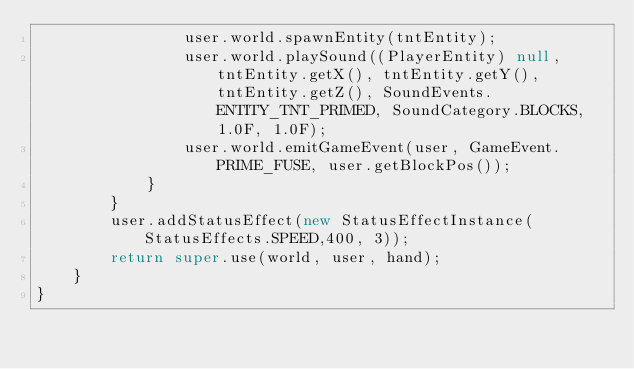Convert code to text. <code><loc_0><loc_0><loc_500><loc_500><_Java_>                user.world.spawnEntity(tntEntity);
                user.world.playSound((PlayerEntity) null, tntEntity.getX(), tntEntity.getY(), tntEntity.getZ(), SoundEvents.ENTITY_TNT_PRIMED, SoundCategory.BLOCKS, 1.0F, 1.0F);
                user.world.emitGameEvent(user, GameEvent.PRIME_FUSE, user.getBlockPos());
            }
        }
        user.addStatusEffect(new StatusEffectInstance(StatusEffects.SPEED,400, 3));
        return super.use(world, user, hand);
    }
}
</code> 